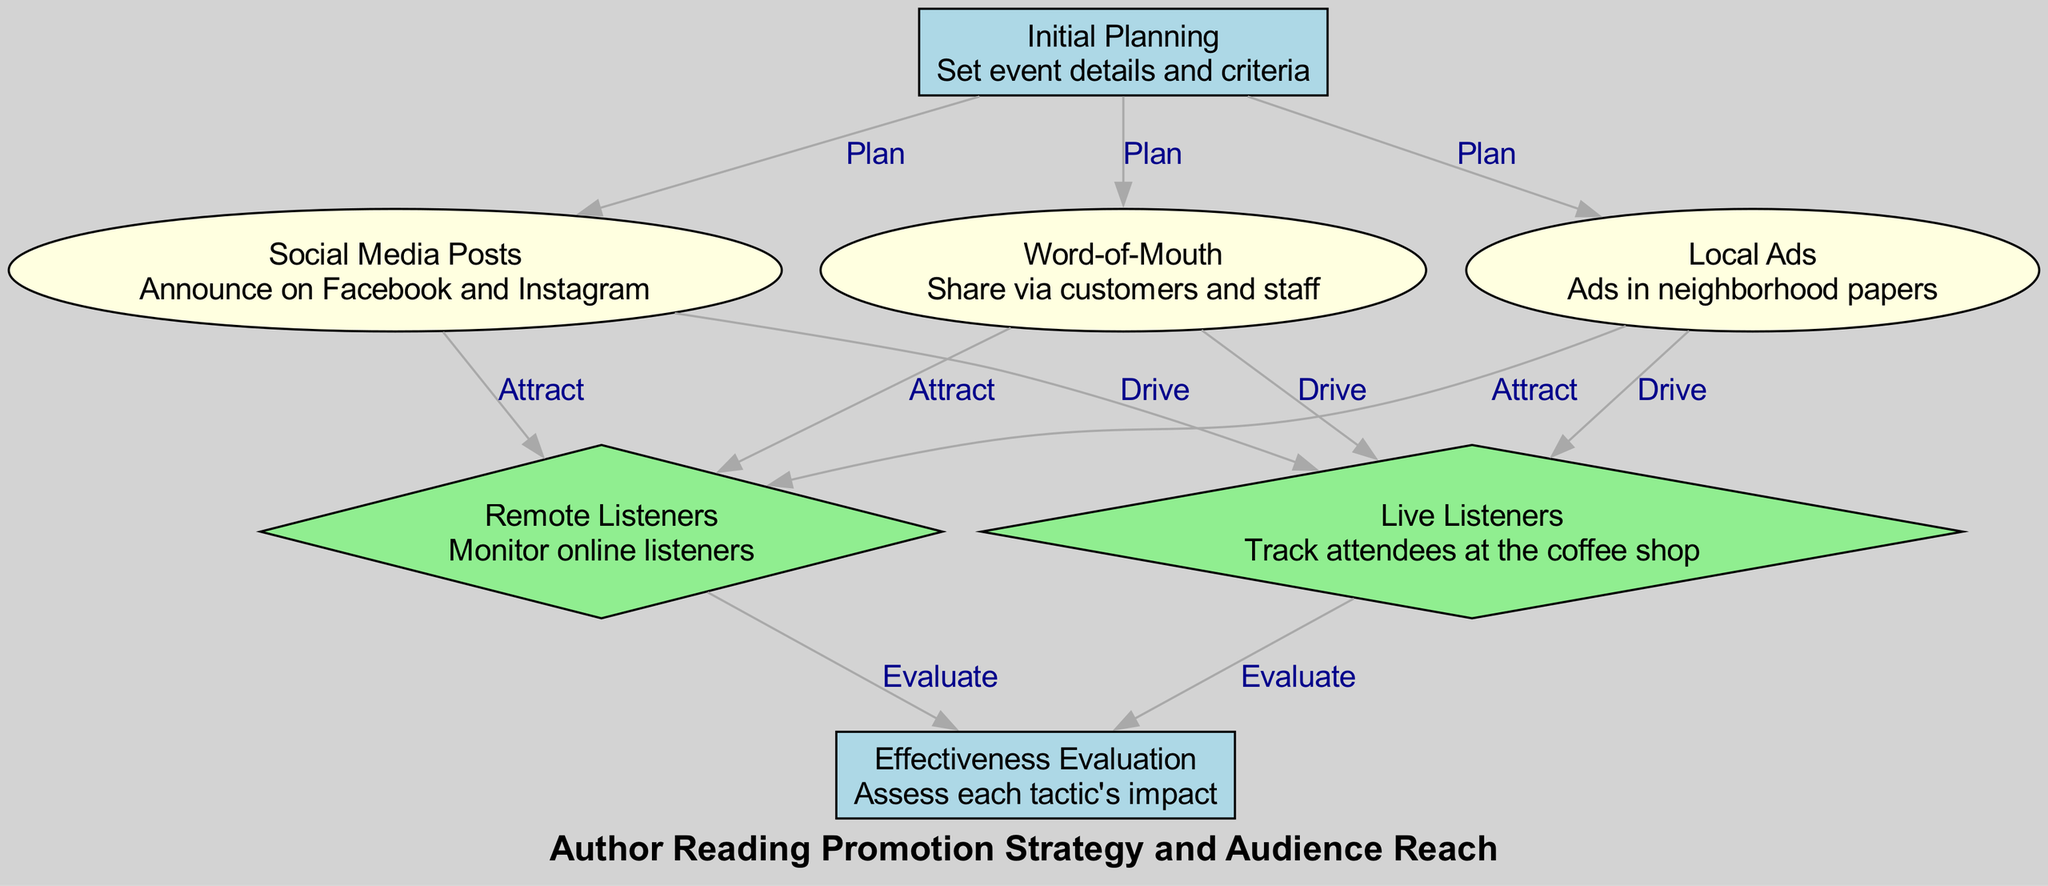What is the first step in the promotion strategy? The diagram shows "Initial Planning" at the top, indicating that it is the first step in the promotion strategy.
Answer: Initial Planning How many promotion tactics are displayed in the diagram? By counting the nodes labeled as "tactic," there are three: Social Media Posts, Local Ads, and Word-of-Mouth.
Answer: 3 What is the outcome related to live listeners? The node labeled "Live Listeners" specifically tracks attendees at the coffee shop, which is the outcome related to live listeners.
Answer: Live Listeners Which promotion tactic aims to drive both live and remote listeners? Each tactic—Social Media Posts, Local Ads, and Word-of-Mouth—has connections labeled "Drive" for live listeners and "Attract" for remote listeners, showing they all aim to drive both.
Answer: All tactics What is the final step in the evaluation process? The final evaluation step is indicated by the node labeled "Effectiveness Evaluation," which assesses the impact of each promotion tactic after both live and remote listener outcomes are considered.
Answer: Effectiveness Evaluation Which tactic is connected to remote listeners? Both Social Media Posts and Local Ads, along with Word-of-Mouth, are connected to the "Remote Listeners" node, showing their aim to attract remote listeners.
Answer: All tactics What type of diagram is used in this visualization? The diagram is categorized as a "Social Science Diagram," specifically focused on promotion strategies and audience reach in the context of author readings.
Answer: Social Science Diagram How is effectiveness evaluated according to the diagram? The effectiveness of each tactic is evaluated based on the outcomes from both live listeners and remote listeners, as shown by the connections leading to the Effectiveness Evaluation node.
Answer: Based on outcomes 